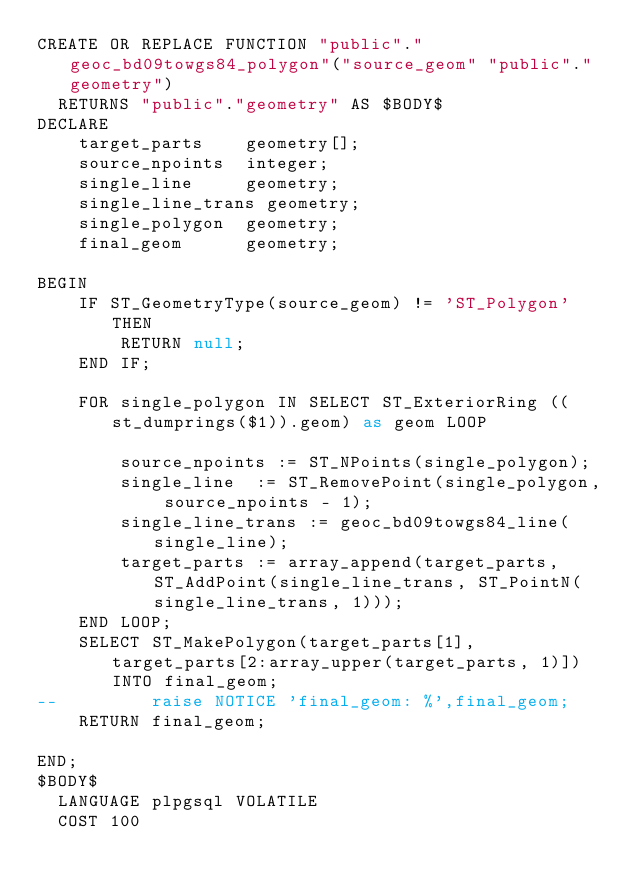Convert code to text. <code><loc_0><loc_0><loc_500><loc_500><_SQL_>CREATE OR REPLACE FUNCTION "public"."geoc_bd09towgs84_polygon"("source_geom" "public"."geometry")
  RETURNS "public"."geometry" AS $BODY$
DECLARE
    target_parts    geometry[];
    source_npoints  integer;
    single_line     geometry;
    single_line_trans geometry;
    single_polygon  geometry;
    final_geom      geometry;

BEGIN
    IF ST_GeometryType(source_geom) != 'ST_Polygon' THEN
        RETURN null;
    END IF;

    FOR single_polygon IN SELECT ST_ExteriorRing ((st_dumprings($1)).geom) as geom LOOP				
        source_npoints := ST_NPoints(single_polygon); 
        single_line  := ST_RemovePoint(single_polygon, source_npoints - 1);  
        single_line_trans := geoc_bd09towgs84_line(single_line);  
        target_parts := array_append(target_parts, ST_AddPoint(single_line_trans, ST_PointN(single_line_trans, 1)));  
    END LOOP;
    SELECT ST_MakePolygon(target_parts[1], target_parts[2:array_upper(target_parts, 1)]) INTO final_geom;  
--         raise NOTICE 'final_geom: %',final_geom;
    RETURN final_geom;

END;
$BODY$
  LANGUAGE plpgsql VOLATILE
  COST 100</code> 